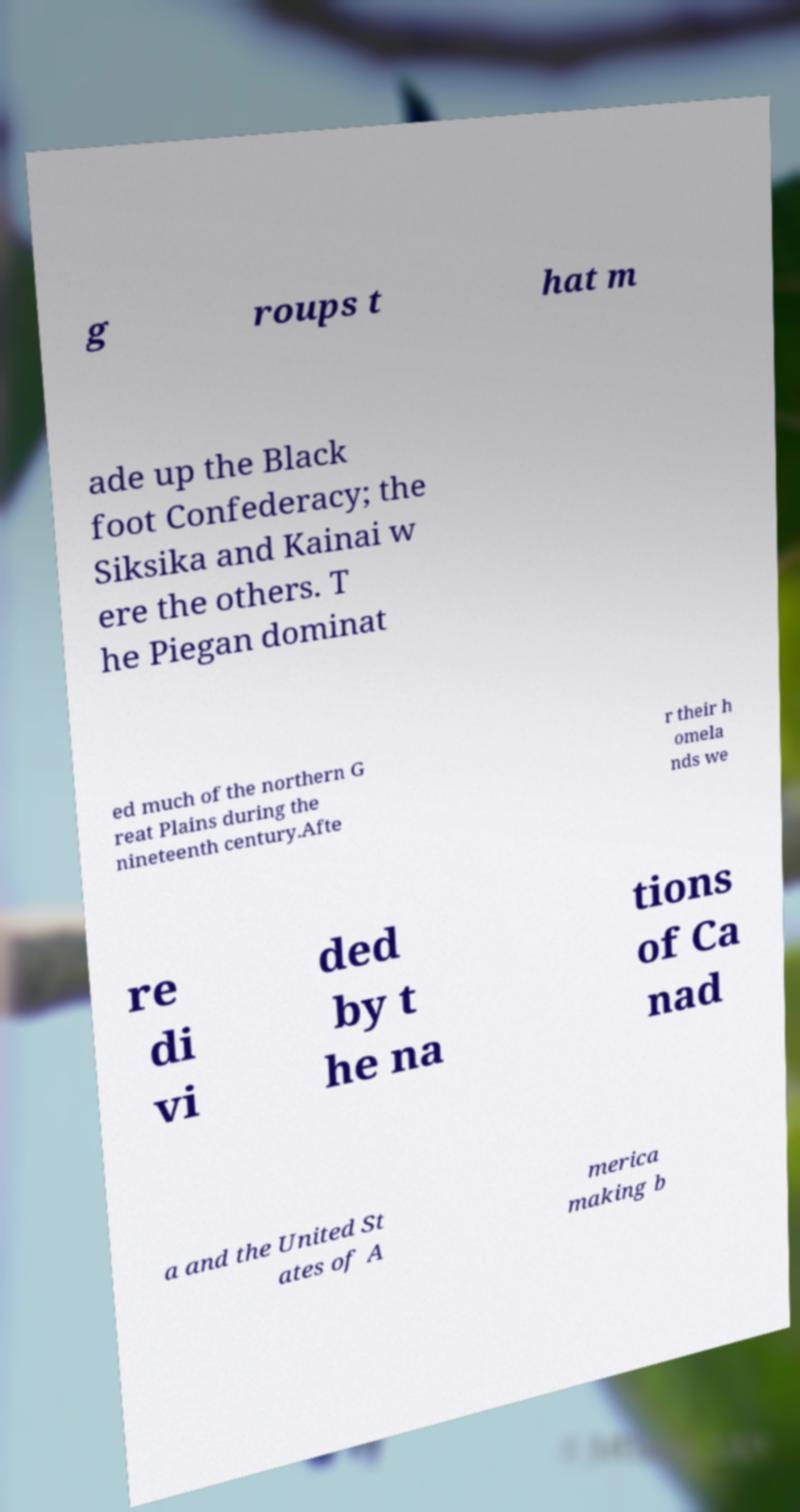Can you read and provide the text displayed in the image?This photo seems to have some interesting text. Can you extract and type it out for me? g roups t hat m ade up the Black foot Confederacy; the Siksika and Kainai w ere the others. T he Piegan dominat ed much of the northern G reat Plains during the nineteenth century.Afte r their h omela nds we re di vi ded by t he na tions of Ca nad a and the United St ates of A merica making b 